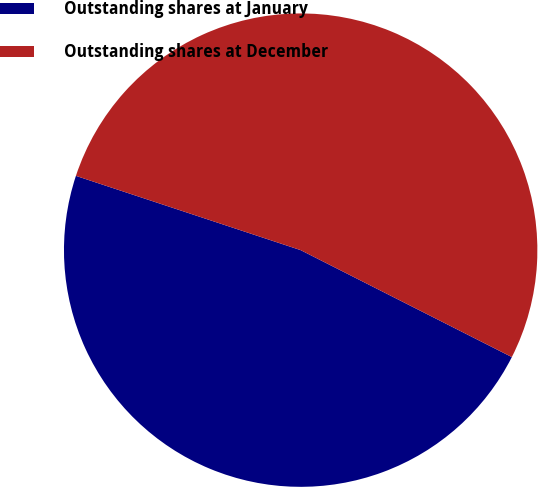Convert chart to OTSL. <chart><loc_0><loc_0><loc_500><loc_500><pie_chart><fcel>Outstanding shares at January<fcel>Outstanding shares at December<nl><fcel>47.62%<fcel>52.38%<nl></chart> 